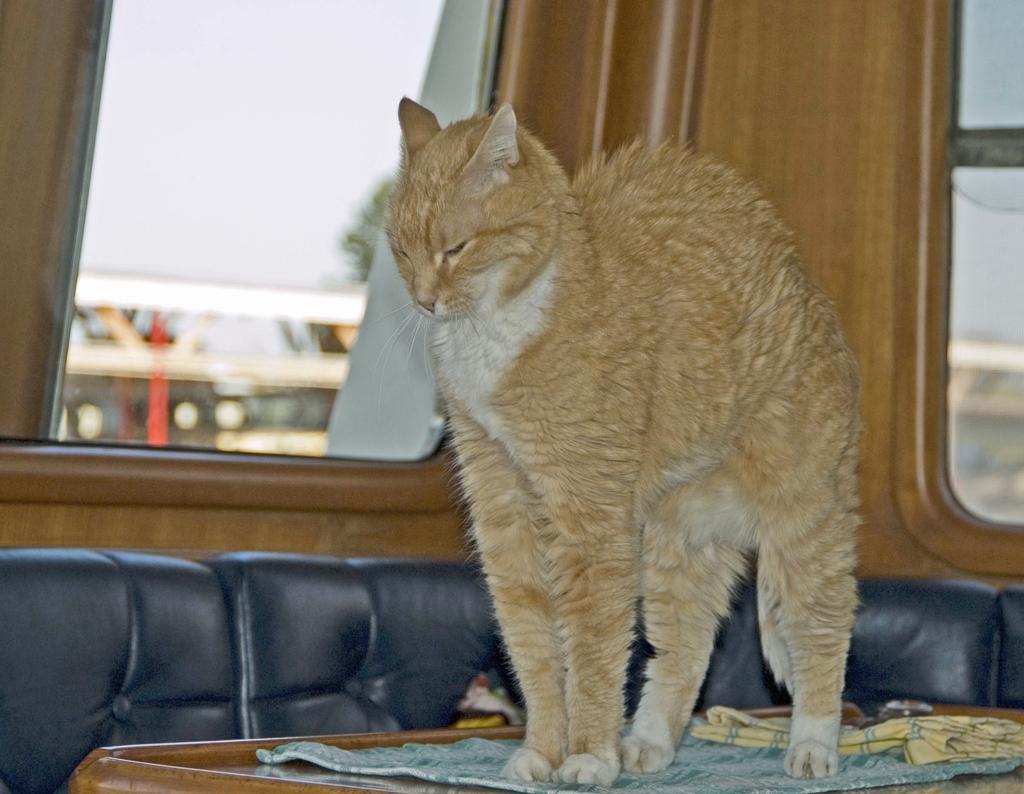Please provide a concise description of this image. In the given image i can see a cat standing on the wooden table,sofa and window. 